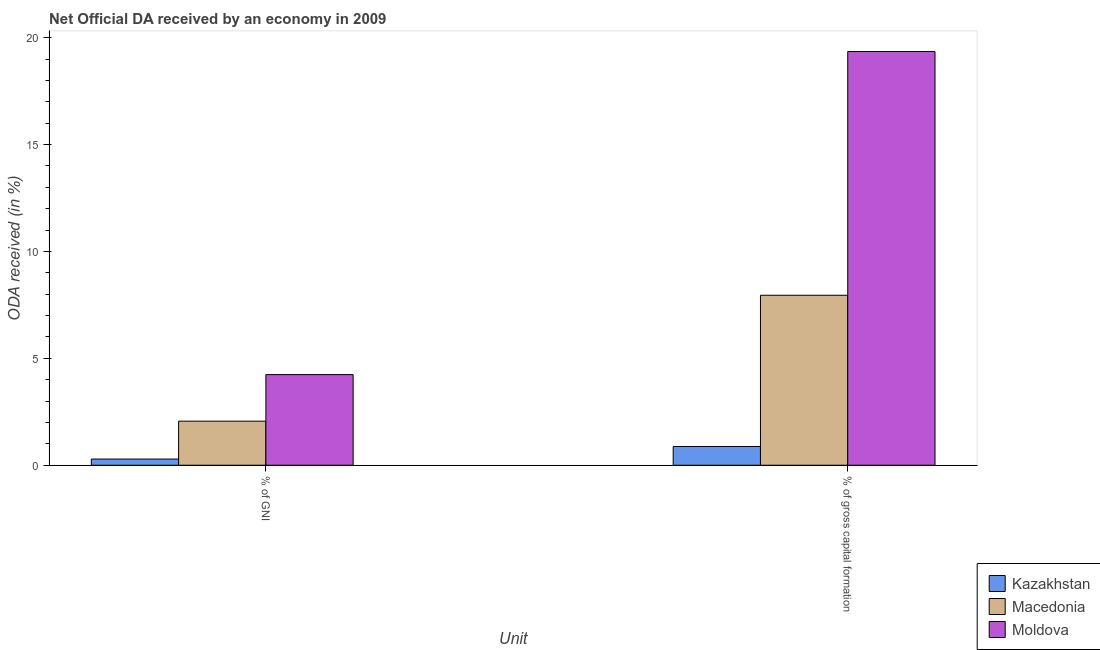How many groups of bars are there?
Give a very brief answer. 2. How many bars are there on the 2nd tick from the right?
Keep it short and to the point. 3. What is the label of the 2nd group of bars from the left?
Make the answer very short. % of gross capital formation. What is the oda received as percentage of gross capital formation in Kazakhstan?
Offer a terse response. 0.88. Across all countries, what is the maximum oda received as percentage of gross capital formation?
Provide a succinct answer. 19.36. Across all countries, what is the minimum oda received as percentage of gross capital formation?
Provide a short and direct response. 0.88. In which country was the oda received as percentage of gross capital formation maximum?
Ensure brevity in your answer.  Moldova. In which country was the oda received as percentage of gni minimum?
Your response must be concise. Kazakhstan. What is the total oda received as percentage of gross capital formation in the graph?
Keep it short and to the point. 28.18. What is the difference between the oda received as percentage of gni in Macedonia and that in Kazakhstan?
Your answer should be compact. 1.77. What is the difference between the oda received as percentage of gni in Kazakhstan and the oda received as percentage of gross capital formation in Macedonia?
Make the answer very short. -7.66. What is the average oda received as percentage of gni per country?
Give a very brief answer. 2.2. What is the difference between the oda received as percentage of gross capital formation and oda received as percentage of gni in Kazakhstan?
Ensure brevity in your answer.  0.59. What is the ratio of the oda received as percentage of gross capital formation in Moldova to that in Kazakhstan?
Keep it short and to the point. 22.07. Is the oda received as percentage of gni in Kazakhstan less than that in Moldova?
Offer a very short reply. Yes. In how many countries, is the oda received as percentage of gross capital formation greater than the average oda received as percentage of gross capital formation taken over all countries?
Keep it short and to the point. 1. What does the 2nd bar from the left in % of gross capital formation represents?
Offer a very short reply. Macedonia. What does the 2nd bar from the right in % of gross capital formation represents?
Ensure brevity in your answer.  Macedonia. How many bars are there?
Give a very brief answer. 6. How many countries are there in the graph?
Provide a succinct answer. 3. What is the difference between two consecutive major ticks on the Y-axis?
Make the answer very short. 5. Are the values on the major ticks of Y-axis written in scientific E-notation?
Provide a succinct answer. No. Does the graph contain any zero values?
Offer a terse response. No. Does the graph contain grids?
Keep it short and to the point. No. How many legend labels are there?
Provide a succinct answer. 3. How are the legend labels stacked?
Provide a short and direct response. Vertical. What is the title of the graph?
Your response must be concise. Net Official DA received by an economy in 2009. What is the label or title of the X-axis?
Give a very brief answer. Unit. What is the label or title of the Y-axis?
Ensure brevity in your answer.  ODA received (in %). What is the ODA received (in %) of Kazakhstan in % of GNI?
Make the answer very short. 0.29. What is the ODA received (in %) in Macedonia in % of GNI?
Make the answer very short. 2.06. What is the ODA received (in %) in Moldova in % of GNI?
Provide a succinct answer. 4.24. What is the ODA received (in %) in Kazakhstan in % of gross capital formation?
Provide a short and direct response. 0.88. What is the ODA received (in %) in Macedonia in % of gross capital formation?
Offer a very short reply. 7.95. What is the ODA received (in %) of Moldova in % of gross capital formation?
Offer a terse response. 19.36. Across all Unit, what is the maximum ODA received (in %) of Kazakhstan?
Your answer should be compact. 0.88. Across all Unit, what is the maximum ODA received (in %) of Macedonia?
Offer a terse response. 7.95. Across all Unit, what is the maximum ODA received (in %) of Moldova?
Keep it short and to the point. 19.36. Across all Unit, what is the minimum ODA received (in %) of Kazakhstan?
Offer a terse response. 0.29. Across all Unit, what is the minimum ODA received (in %) of Macedonia?
Ensure brevity in your answer.  2.06. Across all Unit, what is the minimum ODA received (in %) of Moldova?
Your answer should be very brief. 4.24. What is the total ODA received (in %) of Kazakhstan in the graph?
Your answer should be compact. 1.17. What is the total ODA received (in %) in Macedonia in the graph?
Your response must be concise. 10.01. What is the total ODA received (in %) in Moldova in the graph?
Keep it short and to the point. 23.6. What is the difference between the ODA received (in %) of Kazakhstan in % of GNI and that in % of gross capital formation?
Keep it short and to the point. -0.59. What is the difference between the ODA received (in %) in Macedonia in % of GNI and that in % of gross capital formation?
Ensure brevity in your answer.  -5.89. What is the difference between the ODA received (in %) in Moldova in % of GNI and that in % of gross capital formation?
Make the answer very short. -15.11. What is the difference between the ODA received (in %) of Kazakhstan in % of GNI and the ODA received (in %) of Macedonia in % of gross capital formation?
Provide a succinct answer. -7.66. What is the difference between the ODA received (in %) of Kazakhstan in % of GNI and the ODA received (in %) of Moldova in % of gross capital formation?
Offer a terse response. -19.07. What is the difference between the ODA received (in %) of Macedonia in % of GNI and the ODA received (in %) of Moldova in % of gross capital formation?
Provide a short and direct response. -17.29. What is the average ODA received (in %) in Kazakhstan per Unit?
Your response must be concise. 0.58. What is the average ODA received (in %) in Macedonia per Unit?
Your response must be concise. 5.01. What is the average ODA received (in %) in Moldova per Unit?
Your response must be concise. 11.8. What is the difference between the ODA received (in %) in Kazakhstan and ODA received (in %) in Macedonia in % of GNI?
Offer a terse response. -1.77. What is the difference between the ODA received (in %) in Kazakhstan and ODA received (in %) in Moldova in % of GNI?
Give a very brief answer. -3.95. What is the difference between the ODA received (in %) in Macedonia and ODA received (in %) in Moldova in % of GNI?
Offer a terse response. -2.18. What is the difference between the ODA received (in %) of Kazakhstan and ODA received (in %) of Macedonia in % of gross capital formation?
Your answer should be very brief. -7.08. What is the difference between the ODA received (in %) in Kazakhstan and ODA received (in %) in Moldova in % of gross capital formation?
Your answer should be compact. -18.48. What is the difference between the ODA received (in %) of Macedonia and ODA received (in %) of Moldova in % of gross capital formation?
Offer a terse response. -11.4. What is the ratio of the ODA received (in %) of Kazakhstan in % of GNI to that in % of gross capital formation?
Offer a very short reply. 0.33. What is the ratio of the ODA received (in %) of Macedonia in % of GNI to that in % of gross capital formation?
Provide a succinct answer. 0.26. What is the ratio of the ODA received (in %) in Moldova in % of GNI to that in % of gross capital formation?
Your answer should be compact. 0.22. What is the difference between the highest and the second highest ODA received (in %) of Kazakhstan?
Offer a terse response. 0.59. What is the difference between the highest and the second highest ODA received (in %) in Macedonia?
Offer a very short reply. 5.89. What is the difference between the highest and the second highest ODA received (in %) of Moldova?
Give a very brief answer. 15.11. What is the difference between the highest and the lowest ODA received (in %) in Kazakhstan?
Offer a very short reply. 0.59. What is the difference between the highest and the lowest ODA received (in %) in Macedonia?
Make the answer very short. 5.89. What is the difference between the highest and the lowest ODA received (in %) of Moldova?
Give a very brief answer. 15.11. 